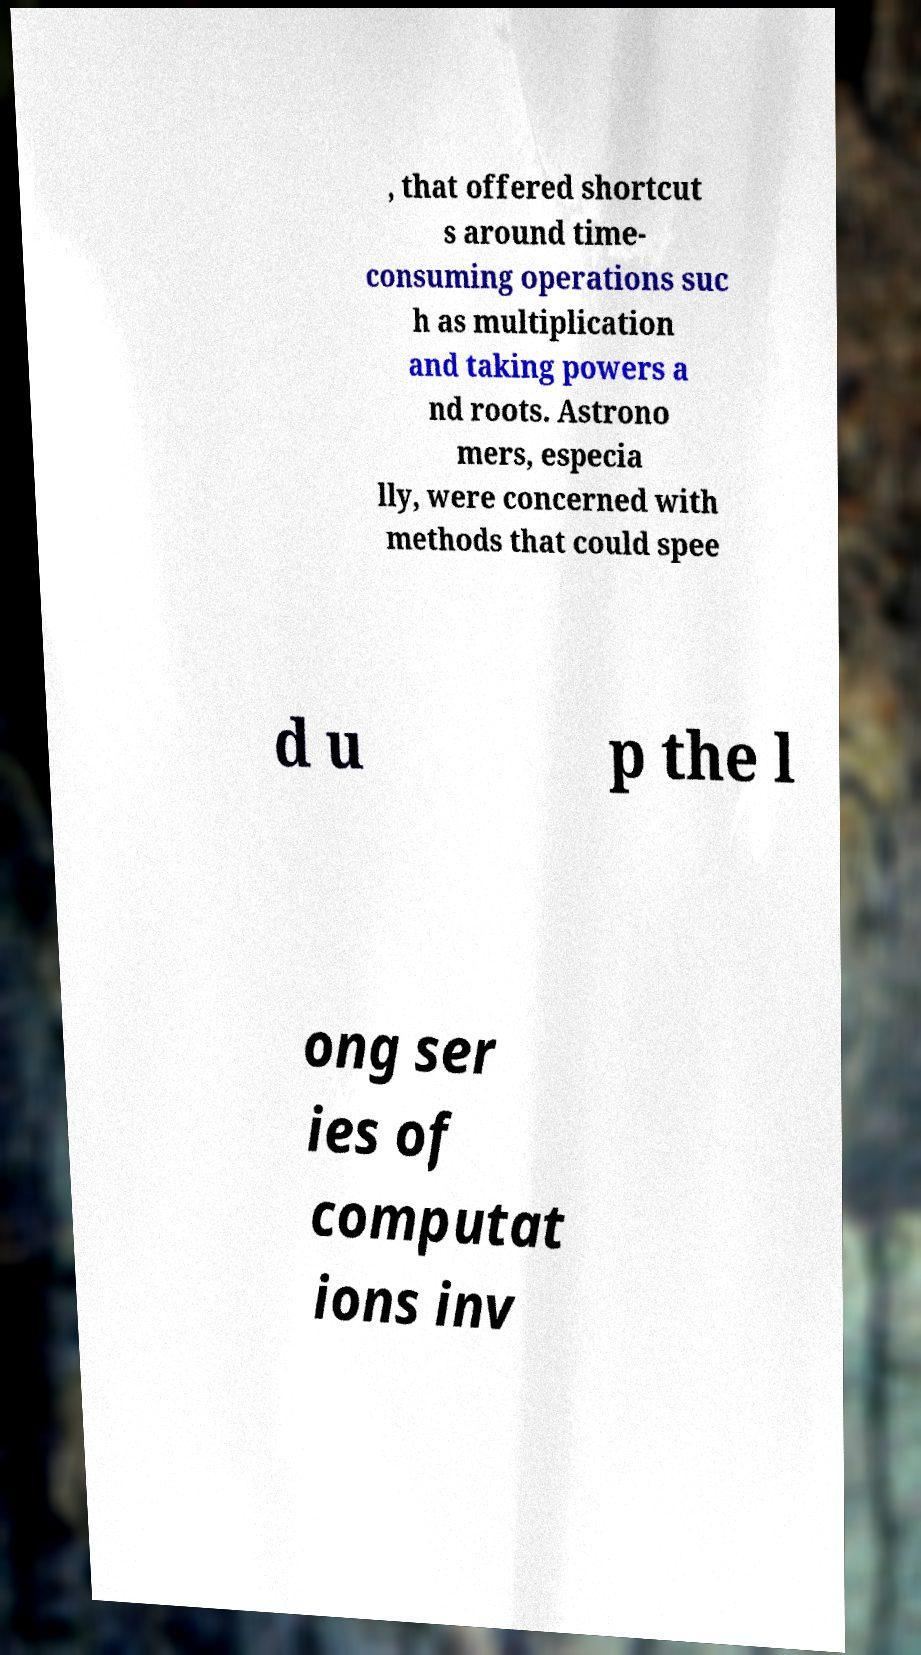There's text embedded in this image that I need extracted. Can you transcribe it verbatim? , that offered shortcut s around time- consuming operations suc h as multiplication and taking powers a nd roots. Astrono mers, especia lly, were concerned with methods that could spee d u p the l ong ser ies of computat ions inv 